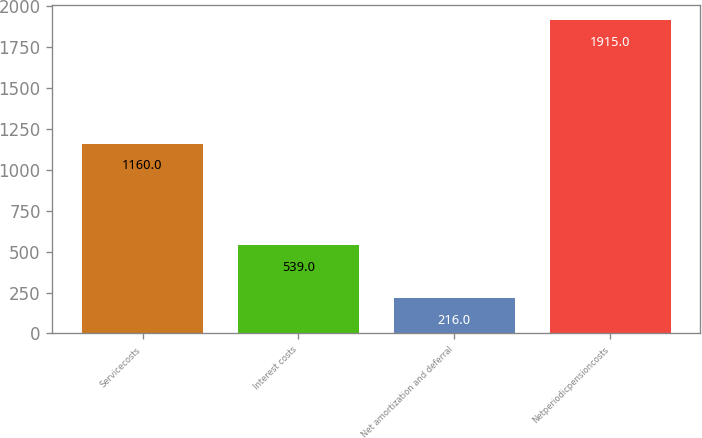<chart> <loc_0><loc_0><loc_500><loc_500><bar_chart><fcel>Servicecosts<fcel>Interest costs<fcel>Net amortization and deferral<fcel>Netperiodicpensioncosts<nl><fcel>1160<fcel>539<fcel>216<fcel>1915<nl></chart> 